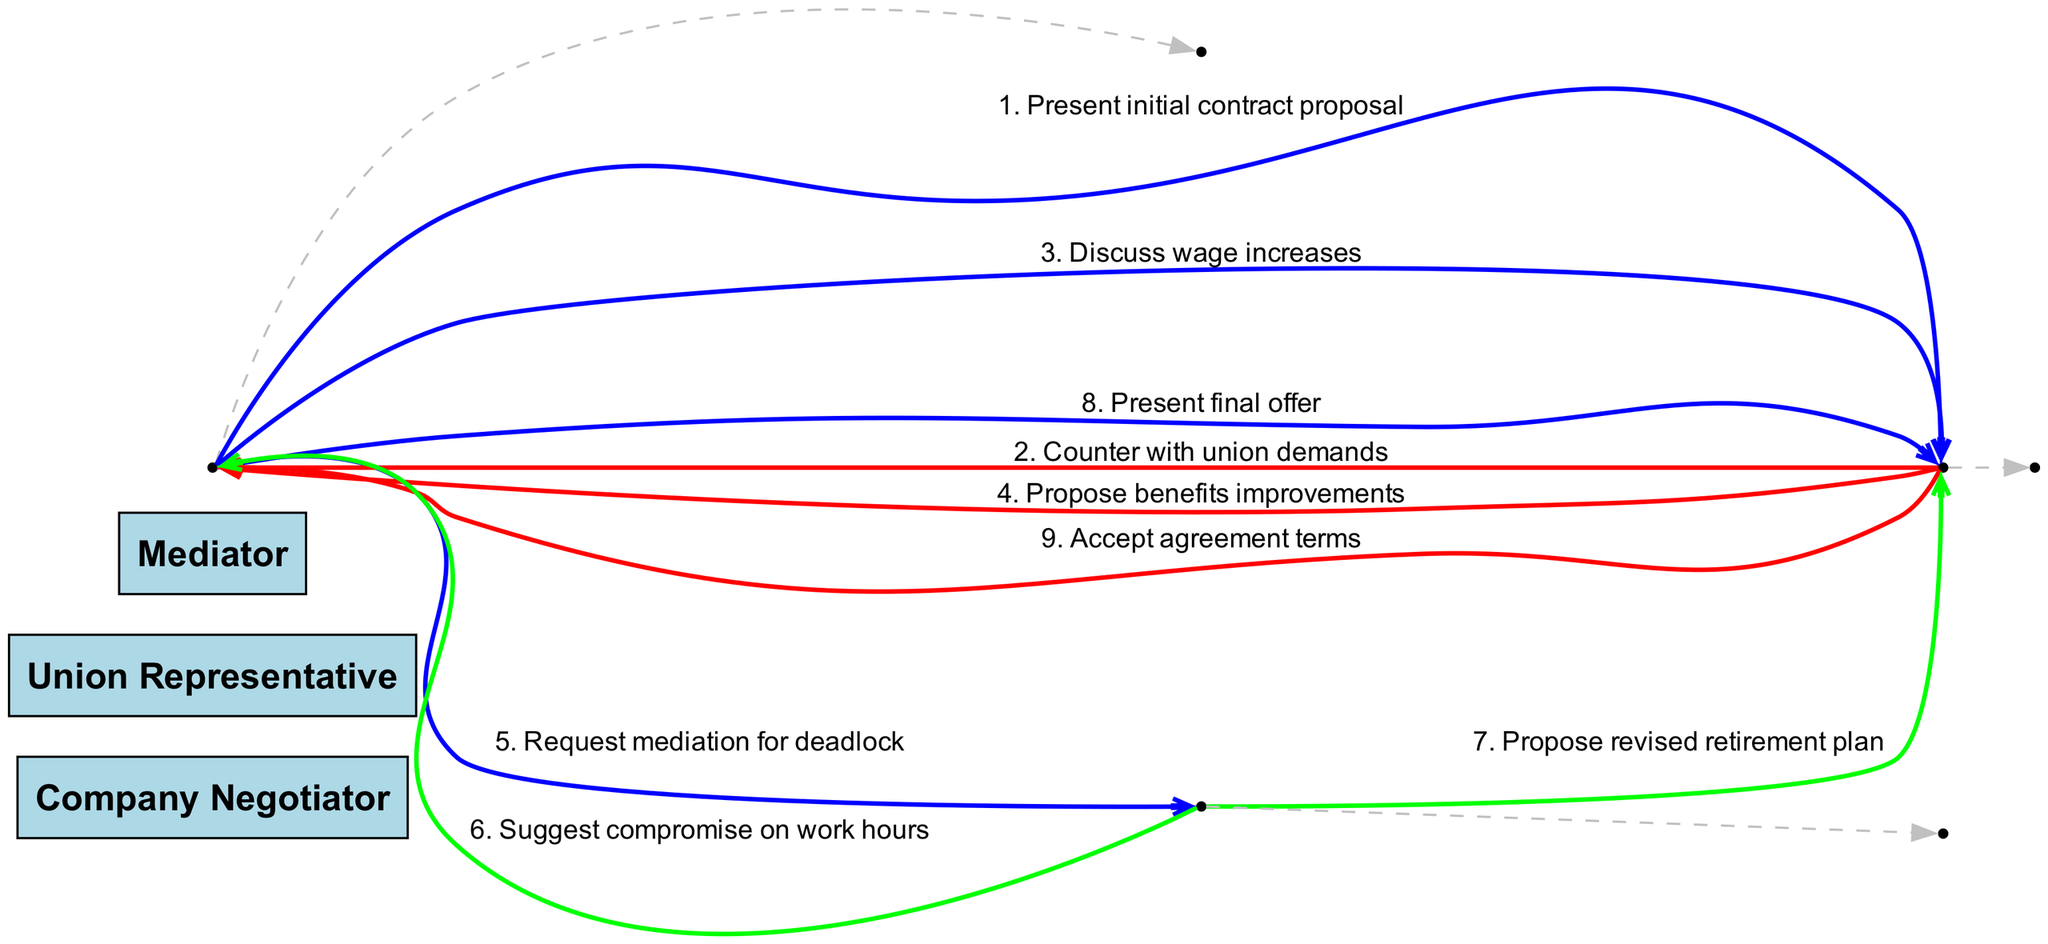What is the first message sent in the negotiation process? The diagram's first message is from the Company Negotiator to the Union Representative, stating "Present initial contract proposal." This indicates the starting point of the negotiation process.
Answer: Present initial contract proposal How many actors are involved in the negotiation sequence? The diagram lists three actors involved in the negotiation: Company Negotiator, Union Representative, and Mediator. This is a straightforward count of the distinct entities participating in the process.
Answer: Three Which actor sends the final message? The last message in the sequence is from the Union Representative to the Company Negotiator, stating "Accept agreement terms." This reveals that the conclusion of the negotiation is driven by the Union's acceptance.
Answer: Union Representative What color represents messages from the Company Negotiator? The edges from the Company Negotiator are colored blue in the diagram. This visual distinction helps to identify the contributions from this actor in the negotiation flow.
Answer: Blue How does mediation influence the negotiation process? The Mediator acts as a participant after the Company Negotiator sends a request for mediation due to a deadlock. The Mediator suggests a compromise on work hours and a revised retirement plan to aid in resolving the impasse. This shows the critical role of the Mediator in steering the negotiations toward potential agreements.
Answer: Suggests compromise Which message leads to the request for mediation? The request for mediation follows the initial back-and-forth messages regarding wages and benefits. Specifically, it is the step where the Company Negotiator feels a deadlock has occurred, prompting them to seek outside assistance.
Answer: Request mediation for deadlock How many messages are exchanged before the request for mediation? There are four messages exchanged prior to the request for mediation: "Present initial contract proposal," "Counter with union demands," "Discuss wage increases," and "Propose benefits improvements." This count indicates that the negotiation had multiple interactions before resorting to mediation.
Answer: Four What type of proposal does the Mediator suggest? The Mediator suggests a compromise on work hours. This indicates that the Mediator's role includes proposing alternative solutions to help resolve disputes between the main negotiators.
Answer: Compromise on work hours What is the role of the Mediator in this sequence? The Mediator serves to facilitate discussions and propose compromises after recognizing that negotiations have reached a deadlock. This position is crucial in helping both parties reach an agreement through mediation.
Answer: Facilitate discussions 